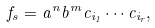<formula> <loc_0><loc_0><loc_500><loc_500>f _ { s } = a ^ { n } b ^ { m } c _ { i _ { 1 } } \cdots c _ { i _ { r } } ,</formula> 